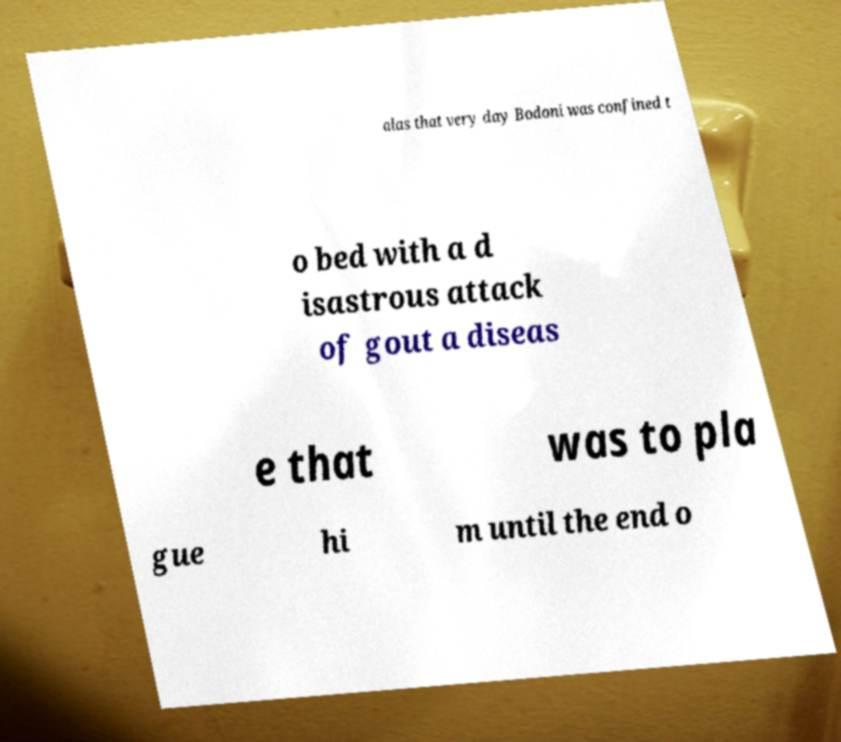What messages or text are displayed in this image? I need them in a readable, typed format. alas that very day Bodoni was confined t o bed with a d isastrous attack of gout a diseas e that was to pla gue hi m until the end o 